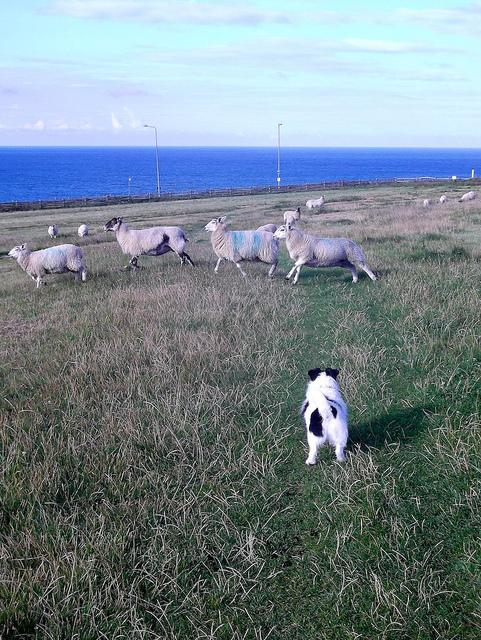What are the blue marks from? Please explain your reasoning. paint. Livestock is marked for various reasons such as breeding or illness 